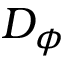<formula> <loc_0><loc_0><loc_500><loc_500>D _ { \phi }</formula> 